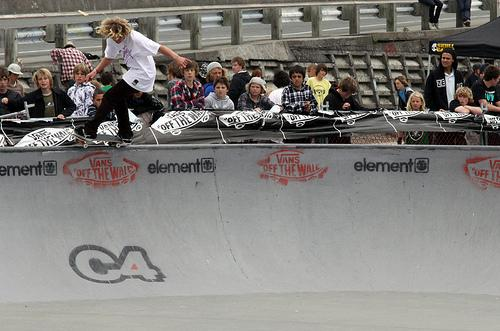Name three tasks that one could perform with this image, based on the given metadata. 3. Object interaction analysis task, studying the interactions between the skateboarder, ramp, and elements in the image. Identify any road barriers or objects located near the road shown in the image. There is a silver guard rail and a road barrier behind the skateboarder, near the road. Describe the appearance and position of the guard rail shown in the image. The guard rail is silver and located on the road behind the people in the upper part of the image. What type of sporting area is shown in the picture, and what activity is the main focus? This is a skatepark with a concrete ramp, and the main focus is a skateboarder doing tricks on the ramp. Mention the clothing and hairstyle of the skateboarder in action. The skateboarder has curly dirty blonde hair, is wearing a white shirt, and is riding a black and white skateboard. What are some notable features about the ramp, including brands and words visible on it? The gray ramp has graffiti and advertisements, featuring the brand name Element, the sponsor Vans Off The Wall, and the name of the ramp, C4. What sentiment or emotions does this image evoke? The image evokes excitement, youthful energy, and a sense of freedom. Analyze the image and estimate the time of day when it was taken. The photo was likely taken in the early afternoon. List three people in the image besides the skateboarder, and describe what they are wearing. 3. A man in a white shirt and black jacket. How many sets of legs can be seen in the upper right of the image, and what are they doing? There are two sets of legs in the upper right, belonging to people who are watching the skaters. 